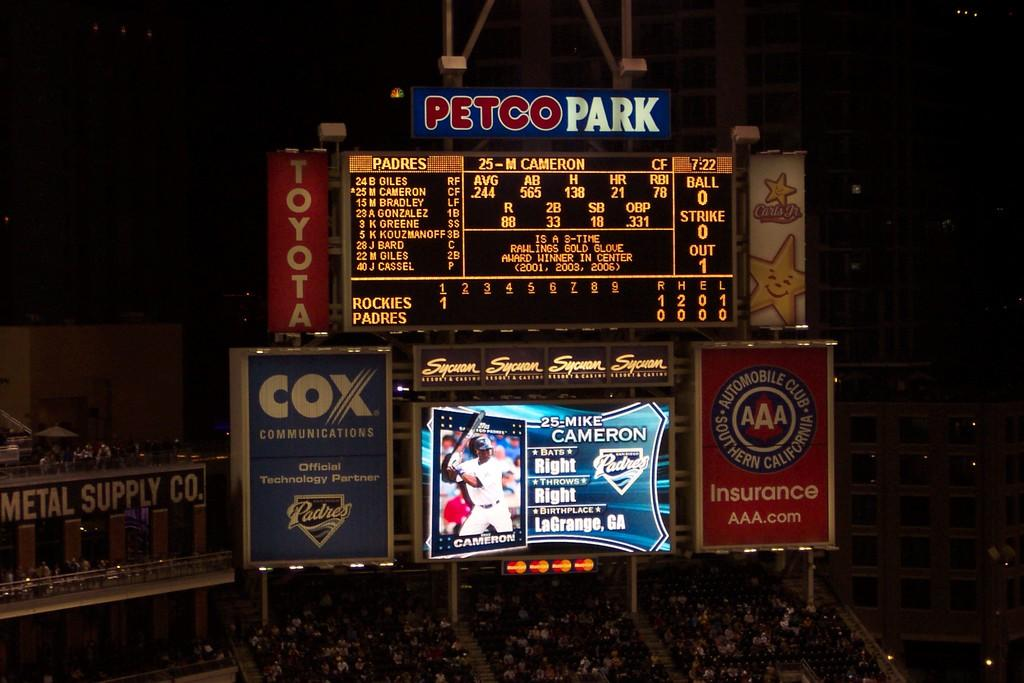<image>
Render a clear and concise summary of the photo. A large digital scoreboard at a baseball stadium with the name Petco Park. 